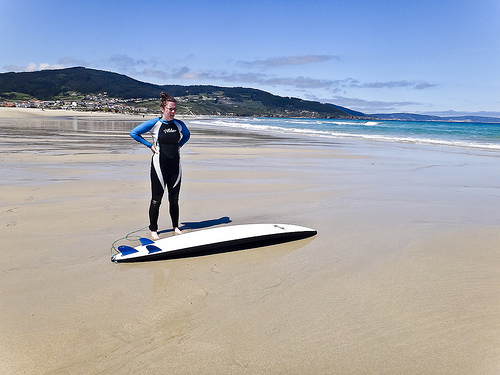Please provide a short description for this region: [0.59, 0.36, 0.79, 0.38]. Here you can see white breaker waves cresting rhythmically in the ocean, a typical scene for surfers seeking the thrill of riding the surf. 